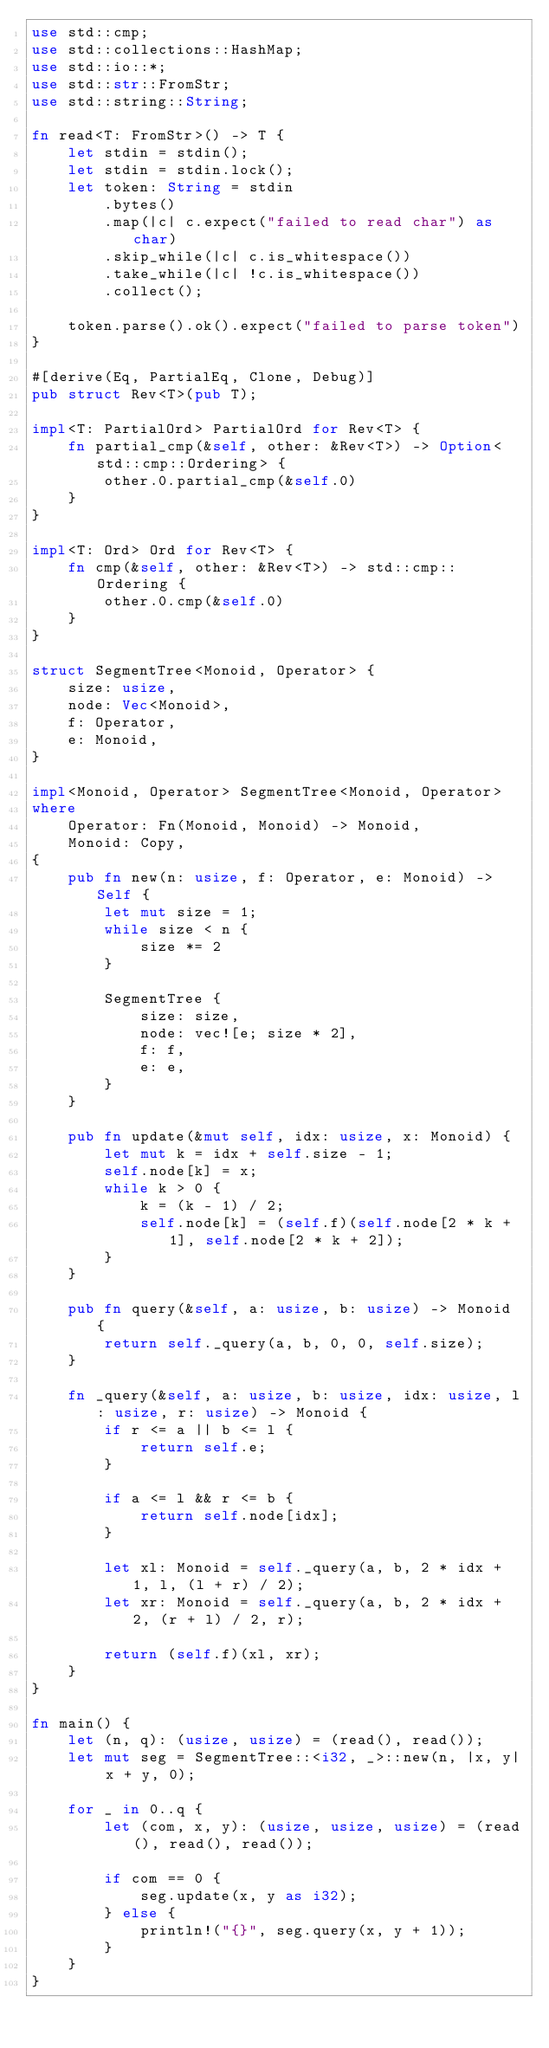<code> <loc_0><loc_0><loc_500><loc_500><_Rust_>use std::cmp;
use std::collections::HashMap;
use std::io::*;
use std::str::FromStr;
use std::string::String;

fn read<T: FromStr>() -> T {
    let stdin = stdin();
    let stdin = stdin.lock();
    let token: String = stdin
        .bytes()
        .map(|c| c.expect("failed to read char") as char)
        .skip_while(|c| c.is_whitespace())
        .take_while(|c| !c.is_whitespace())
        .collect();

    token.parse().ok().expect("failed to parse token")
}

#[derive(Eq, PartialEq, Clone, Debug)]
pub struct Rev<T>(pub T);

impl<T: PartialOrd> PartialOrd for Rev<T> {
    fn partial_cmp(&self, other: &Rev<T>) -> Option<std::cmp::Ordering> {
        other.0.partial_cmp(&self.0)
    }
}

impl<T: Ord> Ord for Rev<T> {
    fn cmp(&self, other: &Rev<T>) -> std::cmp::Ordering {
        other.0.cmp(&self.0)
    }
}

struct SegmentTree<Monoid, Operator> {
    size: usize,
    node: Vec<Monoid>,
    f: Operator,
    e: Monoid,
}

impl<Monoid, Operator> SegmentTree<Monoid, Operator>
where
    Operator: Fn(Monoid, Monoid) -> Monoid,
    Monoid: Copy,
{
    pub fn new(n: usize, f: Operator, e: Monoid) -> Self {
        let mut size = 1;
        while size < n {
            size *= 2
        }

        SegmentTree {
            size: size,
            node: vec![e; size * 2],
            f: f,
            e: e,
        }
    }

    pub fn update(&mut self, idx: usize, x: Monoid) {
        let mut k = idx + self.size - 1;
        self.node[k] = x;
        while k > 0 {
            k = (k - 1) / 2;
            self.node[k] = (self.f)(self.node[2 * k + 1], self.node[2 * k + 2]);
        }
    }

    pub fn query(&self, a: usize, b: usize) -> Monoid {
        return self._query(a, b, 0, 0, self.size);
    }

    fn _query(&self, a: usize, b: usize, idx: usize, l: usize, r: usize) -> Monoid {
        if r <= a || b <= l {
            return self.e;
        }

        if a <= l && r <= b {
            return self.node[idx];
        }

        let xl: Monoid = self._query(a, b, 2 * idx + 1, l, (l + r) / 2);
        let xr: Monoid = self._query(a, b, 2 * idx + 2, (r + l) / 2, r);

        return (self.f)(xl, xr);
    }
}

fn main() {
    let (n, q): (usize, usize) = (read(), read());
    let mut seg = SegmentTree::<i32, _>::new(n, |x, y| x + y, 0);

    for _ in 0..q {
        let (com, x, y): (usize, usize, usize) = (read(), read(), read());

        if com == 0 {
            seg.update(x, y as i32);
        } else {
            println!("{}", seg.query(x, y + 1));
        }
    }
}
</code> 